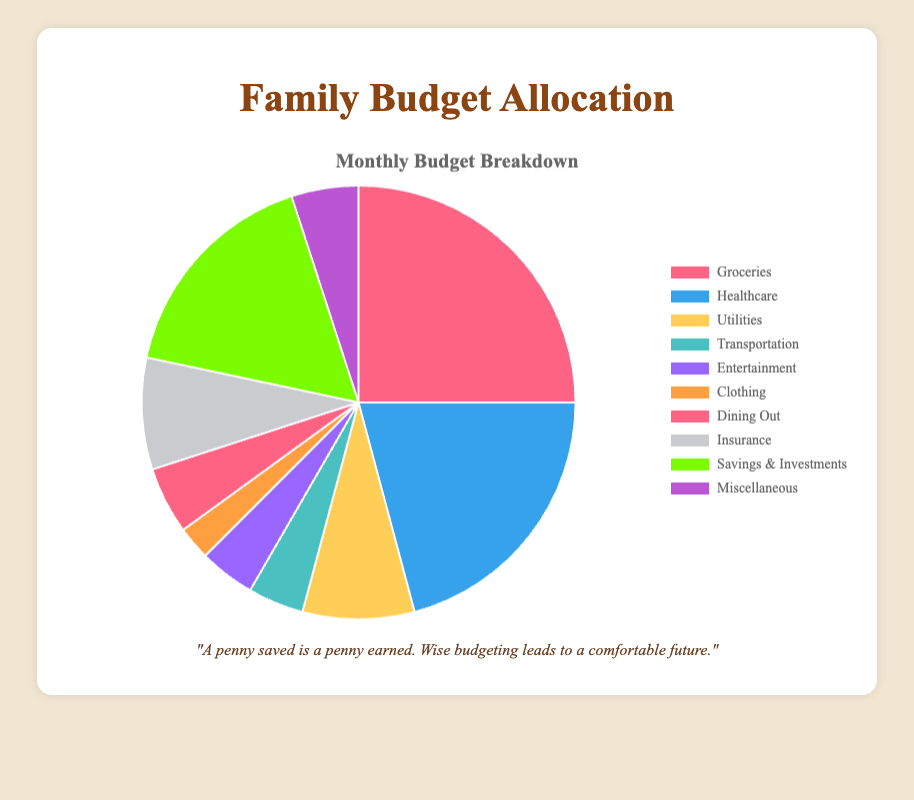What's the total amount allocated to Groceries and Healthcare combined? To find the total amount allocated to Groceries and Healthcare, we sum the amounts allocated to both categories. According to the data, Groceries is $300 and Healthcare is $250. Therefore, $300 + $250 = $550.
Answer: $550 Which category has the smallest allocation? To determine the smallest allocation, we need to compare the amounts of all categories. According to the data, the smallest amounts allocated are $30 for Clothing.
Answer: Clothing What is the percentage of the budget allocated to Savings & Investments? To find the percentage, we first calculate the total budget. Adding all amounts: $300 + $250 + $100 + $50 + $50 + $30 + $60 + $100 + $200 + $60 = $1200. Savings & Investments is $200. Therefore, the percentage is ($200 / $1200) * 100 = 16.67%.
Answer: 16.67% Which category is allocated more, Dining Out or Miscellaneous? We need to compare the amounts allocated to Dining Out and Miscellaneous. Dining Out is $60 and Miscellaneous is also $60. So, they are allocated equally.
Answer: They are equal What is the difference between the largest and smallest allocations? The largest allocation is for Groceries ($300) and the smallest is for Clothing ($30). The difference is $300 - $30 = $270.
Answer: $270 How much more is allocated to Groceries compared to Entertainment? We need to subtract the amount allocated to Entertainment from Groceries. Groceries is $300 and Entertainment is $50. So, $300 - $50 = $250.
Answer: $250 What is the average amount allocated per category? First, we find the total budget by summing all the categories: $300 + $250 + $100 + $50 + $50 + $30 + $60 + $100 + $200 + $60 = $1200. There are 10 categories, so the average is $1200 / 10 = $120.
Answer: $120 If we combined Utilities and Insurance, what would their total allocation be? We sum the amounts for Utilities and Insurance. Utilities is $100 and Insurance is $100. Therefore, $100 + $100 = $200.
Answer: $200 What proportion of the budget does Transportation represent compared to the total budget? First, find the total budget: $1200. The amount allocated to Transportation is $50. The proportion is $50 / $1200 = 0.0417, which translates to 4.17%.
Answer: 4.17% What color represents the category with the second highest allocation? The second highest allocation is Healthcare, which is $250. According to the chart colors specified, Healthcare is represented by the blue color.
Answer: Blue 